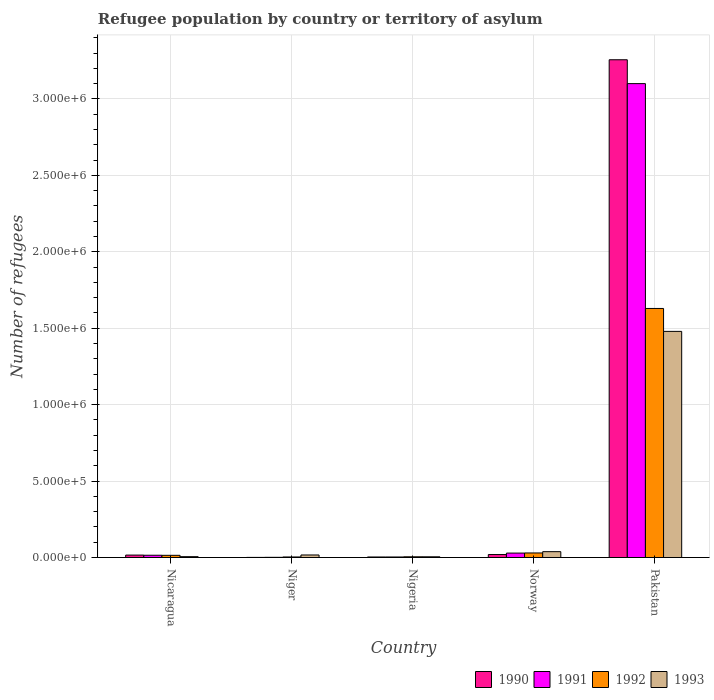How many different coloured bars are there?
Give a very brief answer. 4. How many groups of bars are there?
Ensure brevity in your answer.  5. Are the number of bars per tick equal to the number of legend labels?
Give a very brief answer. Yes. Are the number of bars on each tick of the X-axis equal?
Keep it short and to the point. Yes. How many bars are there on the 3rd tick from the right?
Ensure brevity in your answer.  4. What is the label of the 5th group of bars from the left?
Ensure brevity in your answer.  Pakistan. What is the number of refugees in 1992 in Nigeria?
Offer a terse response. 4782. Across all countries, what is the maximum number of refugees in 1993?
Your answer should be compact. 1.48e+06. Across all countries, what is the minimum number of refugees in 1990?
Provide a short and direct response. 792. In which country was the number of refugees in 1991 minimum?
Offer a very short reply. Niger. What is the total number of refugees in 1990 in the graph?
Make the answer very short. 3.30e+06. What is the difference between the number of refugees in 1991 in Niger and that in Nigeria?
Offer a very short reply. -2188. What is the difference between the number of refugees in 1991 in Nigeria and the number of refugees in 1992 in Pakistan?
Your answer should be very brief. -1.63e+06. What is the average number of refugees in 1990 per country?
Your answer should be very brief. 6.59e+05. What is the difference between the number of refugees of/in 1993 and number of refugees of/in 1990 in Niger?
Provide a succinct answer. 1.59e+04. What is the ratio of the number of refugees in 1990 in Nicaragua to that in Nigeria?
Keep it short and to the point. 4.48. Is the number of refugees in 1993 in Nigeria less than that in Pakistan?
Make the answer very short. Yes. What is the difference between the highest and the second highest number of refugees in 1992?
Make the answer very short. 1.61e+06. What is the difference between the highest and the lowest number of refugees in 1993?
Provide a succinct answer. 1.47e+06. What does the 4th bar from the left in Niger represents?
Make the answer very short. 1993. What does the 2nd bar from the right in Pakistan represents?
Give a very brief answer. 1992. Is it the case that in every country, the sum of the number of refugees in 1992 and number of refugees in 1990 is greater than the number of refugees in 1991?
Your answer should be compact. Yes. How many bars are there?
Provide a short and direct response. 20. Are all the bars in the graph horizontal?
Your response must be concise. No. What is the difference between two consecutive major ticks on the Y-axis?
Your answer should be very brief. 5.00e+05. Are the values on the major ticks of Y-axis written in scientific E-notation?
Keep it short and to the point. Yes. Where does the legend appear in the graph?
Keep it short and to the point. Bottom right. How many legend labels are there?
Keep it short and to the point. 4. What is the title of the graph?
Give a very brief answer. Refugee population by country or territory of asylum. Does "1982" appear as one of the legend labels in the graph?
Offer a very short reply. No. What is the label or title of the Y-axis?
Offer a terse response. Number of refugees. What is the Number of refugees of 1990 in Nicaragua?
Make the answer very short. 1.60e+04. What is the Number of refugees in 1991 in Nicaragua?
Ensure brevity in your answer.  1.49e+04. What is the Number of refugees in 1992 in Nicaragua?
Make the answer very short. 1.44e+04. What is the Number of refugees in 1993 in Nicaragua?
Provide a short and direct response. 5643. What is the Number of refugees of 1990 in Niger?
Make the answer very short. 792. What is the Number of refugees of 1991 in Niger?
Ensure brevity in your answer.  1385. What is the Number of refugees of 1992 in Niger?
Ensure brevity in your answer.  3699. What is the Number of refugees in 1993 in Niger?
Give a very brief answer. 1.67e+04. What is the Number of refugees of 1990 in Nigeria?
Make the answer very short. 3571. What is the Number of refugees of 1991 in Nigeria?
Your answer should be very brief. 3573. What is the Number of refugees of 1992 in Nigeria?
Make the answer very short. 4782. What is the Number of refugees of 1993 in Nigeria?
Provide a short and direct response. 4829. What is the Number of refugees of 1990 in Norway?
Offer a very short reply. 1.96e+04. What is the Number of refugees in 1991 in Norway?
Offer a terse response. 2.91e+04. What is the Number of refugees in 1992 in Norway?
Make the answer very short. 2.98e+04. What is the Number of refugees in 1993 in Norway?
Your answer should be compact. 3.84e+04. What is the Number of refugees of 1990 in Pakistan?
Your answer should be very brief. 3.26e+06. What is the Number of refugees of 1991 in Pakistan?
Ensure brevity in your answer.  3.10e+06. What is the Number of refugees of 1992 in Pakistan?
Provide a short and direct response. 1.63e+06. What is the Number of refugees in 1993 in Pakistan?
Ensure brevity in your answer.  1.48e+06. Across all countries, what is the maximum Number of refugees of 1990?
Keep it short and to the point. 3.26e+06. Across all countries, what is the maximum Number of refugees of 1991?
Your response must be concise. 3.10e+06. Across all countries, what is the maximum Number of refugees in 1992?
Offer a very short reply. 1.63e+06. Across all countries, what is the maximum Number of refugees in 1993?
Offer a terse response. 1.48e+06. Across all countries, what is the minimum Number of refugees of 1990?
Your answer should be very brief. 792. Across all countries, what is the minimum Number of refugees of 1991?
Give a very brief answer. 1385. Across all countries, what is the minimum Number of refugees of 1992?
Provide a short and direct response. 3699. Across all countries, what is the minimum Number of refugees of 1993?
Your answer should be very brief. 4829. What is the total Number of refugees in 1990 in the graph?
Keep it short and to the point. 3.30e+06. What is the total Number of refugees in 1991 in the graph?
Your answer should be compact. 3.15e+06. What is the total Number of refugees in 1992 in the graph?
Make the answer very short. 1.68e+06. What is the total Number of refugees in 1993 in the graph?
Keep it short and to the point. 1.54e+06. What is the difference between the Number of refugees in 1990 in Nicaragua and that in Niger?
Ensure brevity in your answer.  1.52e+04. What is the difference between the Number of refugees of 1991 in Nicaragua and that in Niger?
Ensure brevity in your answer.  1.35e+04. What is the difference between the Number of refugees of 1992 in Nicaragua and that in Niger?
Your answer should be compact. 1.08e+04. What is the difference between the Number of refugees in 1993 in Nicaragua and that in Niger?
Your answer should be very brief. -1.10e+04. What is the difference between the Number of refugees in 1990 in Nicaragua and that in Nigeria?
Offer a terse response. 1.24e+04. What is the difference between the Number of refugees of 1991 in Nicaragua and that in Nigeria?
Provide a succinct answer. 1.14e+04. What is the difference between the Number of refugees of 1992 in Nicaragua and that in Nigeria?
Keep it short and to the point. 9668. What is the difference between the Number of refugees in 1993 in Nicaragua and that in Nigeria?
Provide a short and direct response. 814. What is the difference between the Number of refugees in 1990 in Nicaragua and that in Norway?
Your response must be concise. -3581. What is the difference between the Number of refugees of 1991 in Nicaragua and that in Norway?
Provide a succinct answer. -1.41e+04. What is the difference between the Number of refugees of 1992 in Nicaragua and that in Norway?
Your answer should be compact. -1.54e+04. What is the difference between the Number of refugees of 1993 in Nicaragua and that in Norway?
Your answer should be very brief. -3.27e+04. What is the difference between the Number of refugees in 1990 in Nicaragua and that in Pakistan?
Ensure brevity in your answer.  -3.24e+06. What is the difference between the Number of refugees in 1991 in Nicaragua and that in Pakistan?
Make the answer very short. -3.08e+06. What is the difference between the Number of refugees in 1992 in Nicaragua and that in Pakistan?
Make the answer very short. -1.61e+06. What is the difference between the Number of refugees in 1993 in Nicaragua and that in Pakistan?
Offer a terse response. -1.47e+06. What is the difference between the Number of refugees of 1990 in Niger and that in Nigeria?
Offer a terse response. -2779. What is the difference between the Number of refugees of 1991 in Niger and that in Nigeria?
Give a very brief answer. -2188. What is the difference between the Number of refugees in 1992 in Niger and that in Nigeria?
Offer a terse response. -1083. What is the difference between the Number of refugees of 1993 in Niger and that in Nigeria?
Ensure brevity in your answer.  1.19e+04. What is the difference between the Number of refugees in 1990 in Niger and that in Norway?
Keep it short and to the point. -1.88e+04. What is the difference between the Number of refugees in 1991 in Niger and that in Norway?
Provide a succinct answer. -2.77e+04. What is the difference between the Number of refugees in 1992 in Niger and that in Norway?
Offer a very short reply. -2.61e+04. What is the difference between the Number of refugees of 1993 in Niger and that in Norway?
Your answer should be very brief. -2.17e+04. What is the difference between the Number of refugees of 1990 in Niger and that in Pakistan?
Your answer should be compact. -3.26e+06. What is the difference between the Number of refugees of 1991 in Niger and that in Pakistan?
Keep it short and to the point. -3.10e+06. What is the difference between the Number of refugees of 1992 in Niger and that in Pakistan?
Your response must be concise. -1.63e+06. What is the difference between the Number of refugees in 1993 in Niger and that in Pakistan?
Your response must be concise. -1.46e+06. What is the difference between the Number of refugees of 1990 in Nigeria and that in Norway?
Offer a very short reply. -1.60e+04. What is the difference between the Number of refugees of 1991 in Nigeria and that in Norway?
Your response must be concise. -2.55e+04. What is the difference between the Number of refugees of 1992 in Nigeria and that in Norway?
Your response must be concise. -2.51e+04. What is the difference between the Number of refugees of 1993 in Nigeria and that in Norway?
Provide a succinct answer. -3.35e+04. What is the difference between the Number of refugees of 1990 in Nigeria and that in Pakistan?
Offer a very short reply. -3.25e+06. What is the difference between the Number of refugees of 1991 in Nigeria and that in Pakistan?
Make the answer very short. -3.10e+06. What is the difference between the Number of refugees of 1992 in Nigeria and that in Pakistan?
Make the answer very short. -1.62e+06. What is the difference between the Number of refugees in 1993 in Nigeria and that in Pakistan?
Provide a short and direct response. -1.47e+06. What is the difference between the Number of refugees of 1990 in Norway and that in Pakistan?
Ensure brevity in your answer.  -3.24e+06. What is the difference between the Number of refugees in 1991 in Norway and that in Pakistan?
Offer a terse response. -3.07e+06. What is the difference between the Number of refugees in 1992 in Norway and that in Pakistan?
Provide a succinct answer. -1.60e+06. What is the difference between the Number of refugees of 1993 in Norway and that in Pakistan?
Provide a short and direct response. -1.44e+06. What is the difference between the Number of refugees in 1990 in Nicaragua and the Number of refugees in 1991 in Niger?
Make the answer very short. 1.46e+04. What is the difference between the Number of refugees of 1990 in Nicaragua and the Number of refugees of 1992 in Niger?
Your answer should be compact. 1.23e+04. What is the difference between the Number of refugees of 1990 in Nicaragua and the Number of refugees of 1993 in Niger?
Your answer should be compact. -692. What is the difference between the Number of refugees in 1991 in Nicaragua and the Number of refugees in 1992 in Niger?
Make the answer very short. 1.12e+04. What is the difference between the Number of refugees in 1991 in Nicaragua and the Number of refugees in 1993 in Niger?
Offer a terse response. -1759. What is the difference between the Number of refugees in 1992 in Nicaragua and the Number of refugees in 1993 in Niger?
Ensure brevity in your answer.  -2242. What is the difference between the Number of refugees of 1990 in Nicaragua and the Number of refugees of 1991 in Nigeria?
Give a very brief answer. 1.24e+04. What is the difference between the Number of refugees of 1990 in Nicaragua and the Number of refugees of 1992 in Nigeria?
Offer a very short reply. 1.12e+04. What is the difference between the Number of refugees of 1990 in Nicaragua and the Number of refugees of 1993 in Nigeria?
Provide a succinct answer. 1.12e+04. What is the difference between the Number of refugees in 1991 in Nicaragua and the Number of refugees in 1992 in Nigeria?
Your response must be concise. 1.02e+04. What is the difference between the Number of refugees of 1991 in Nicaragua and the Number of refugees of 1993 in Nigeria?
Provide a succinct answer. 1.01e+04. What is the difference between the Number of refugees in 1992 in Nicaragua and the Number of refugees in 1993 in Nigeria?
Your response must be concise. 9621. What is the difference between the Number of refugees of 1990 in Nicaragua and the Number of refugees of 1991 in Norway?
Your answer should be very brief. -1.31e+04. What is the difference between the Number of refugees in 1990 in Nicaragua and the Number of refugees in 1992 in Norway?
Offer a terse response. -1.38e+04. What is the difference between the Number of refugees of 1990 in Nicaragua and the Number of refugees of 1993 in Norway?
Make the answer very short. -2.24e+04. What is the difference between the Number of refugees of 1991 in Nicaragua and the Number of refugees of 1992 in Norway?
Make the answer very short. -1.49e+04. What is the difference between the Number of refugees in 1991 in Nicaragua and the Number of refugees in 1993 in Norway?
Keep it short and to the point. -2.34e+04. What is the difference between the Number of refugees of 1992 in Nicaragua and the Number of refugees of 1993 in Norway?
Provide a short and direct response. -2.39e+04. What is the difference between the Number of refugees in 1990 in Nicaragua and the Number of refugees in 1991 in Pakistan?
Your answer should be compact. -3.08e+06. What is the difference between the Number of refugees in 1990 in Nicaragua and the Number of refugees in 1992 in Pakistan?
Your answer should be compact. -1.61e+06. What is the difference between the Number of refugees in 1990 in Nicaragua and the Number of refugees in 1993 in Pakistan?
Offer a very short reply. -1.46e+06. What is the difference between the Number of refugees of 1991 in Nicaragua and the Number of refugees of 1992 in Pakistan?
Your answer should be very brief. -1.61e+06. What is the difference between the Number of refugees of 1991 in Nicaragua and the Number of refugees of 1993 in Pakistan?
Your answer should be compact. -1.46e+06. What is the difference between the Number of refugees of 1992 in Nicaragua and the Number of refugees of 1993 in Pakistan?
Make the answer very short. -1.46e+06. What is the difference between the Number of refugees of 1990 in Niger and the Number of refugees of 1991 in Nigeria?
Make the answer very short. -2781. What is the difference between the Number of refugees of 1990 in Niger and the Number of refugees of 1992 in Nigeria?
Provide a short and direct response. -3990. What is the difference between the Number of refugees in 1990 in Niger and the Number of refugees in 1993 in Nigeria?
Make the answer very short. -4037. What is the difference between the Number of refugees of 1991 in Niger and the Number of refugees of 1992 in Nigeria?
Your answer should be compact. -3397. What is the difference between the Number of refugees in 1991 in Niger and the Number of refugees in 1993 in Nigeria?
Provide a short and direct response. -3444. What is the difference between the Number of refugees in 1992 in Niger and the Number of refugees in 1993 in Nigeria?
Offer a terse response. -1130. What is the difference between the Number of refugees in 1990 in Niger and the Number of refugees in 1991 in Norway?
Offer a very short reply. -2.83e+04. What is the difference between the Number of refugees in 1990 in Niger and the Number of refugees in 1992 in Norway?
Provide a succinct answer. -2.91e+04. What is the difference between the Number of refugees of 1990 in Niger and the Number of refugees of 1993 in Norway?
Give a very brief answer. -3.76e+04. What is the difference between the Number of refugees in 1991 in Niger and the Number of refugees in 1992 in Norway?
Make the answer very short. -2.85e+04. What is the difference between the Number of refugees in 1991 in Niger and the Number of refugees in 1993 in Norway?
Your answer should be very brief. -3.70e+04. What is the difference between the Number of refugees in 1992 in Niger and the Number of refugees in 1993 in Norway?
Offer a very short reply. -3.47e+04. What is the difference between the Number of refugees of 1990 in Niger and the Number of refugees of 1991 in Pakistan?
Ensure brevity in your answer.  -3.10e+06. What is the difference between the Number of refugees in 1990 in Niger and the Number of refugees in 1992 in Pakistan?
Provide a short and direct response. -1.63e+06. What is the difference between the Number of refugees of 1990 in Niger and the Number of refugees of 1993 in Pakistan?
Provide a succinct answer. -1.48e+06. What is the difference between the Number of refugees of 1991 in Niger and the Number of refugees of 1992 in Pakistan?
Provide a short and direct response. -1.63e+06. What is the difference between the Number of refugees in 1991 in Niger and the Number of refugees in 1993 in Pakistan?
Provide a short and direct response. -1.48e+06. What is the difference between the Number of refugees in 1992 in Niger and the Number of refugees in 1993 in Pakistan?
Ensure brevity in your answer.  -1.48e+06. What is the difference between the Number of refugees in 1990 in Nigeria and the Number of refugees in 1991 in Norway?
Your answer should be compact. -2.55e+04. What is the difference between the Number of refugees of 1990 in Nigeria and the Number of refugees of 1992 in Norway?
Provide a succinct answer. -2.63e+04. What is the difference between the Number of refugees of 1990 in Nigeria and the Number of refugees of 1993 in Norway?
Provide a succinct answer. -3.48e+04. What is the difference between the Number of refugees in 1991 in Nigeria and the Number of refugees in 1992 in Norway?
Give a very brief answer. -2.63e+04. What is the difference between the Number of refugees in 1991 in Nigeria and the Number of refugees in 1993 in Norway?
Offer a terse response. -3.48e+04. What is the difference between the Number of refugees in 1992 in Nigeria and the Number of refugees in 1993 in Norway?
Offer a very short reply. -3.36e+04. What is the difference between the Number of refugees in 1990 in Nigeria and the Number of refugees in 1991 in Pakistan?
Provide a short and direct response. -3.10e+06. What is the difference between the Number of refugees in 1990 in Nigeria and the Number of refugees in 1992 in Pakistan?
Ensure brevity in your answer.  -1.63e+06. What is the difference between the Number of refugees in 1990 in Nigeria and the Number of refugees in 1993 in Pakistan?
Give a very brief answer. -1.48e+06. What is the difference between the Number of refugees of 1991 in Nigeria and the Number of refugees of 1992 in Pakistan?
Give a very brief answer. -1.63e+06. What is the difference between the Number of refugees of 1991 in Nigeria and the Number of refugees of 1993 in Pakistan?
Your answer should be very brief. -1.48e+06. What is the difference between the Number of refugees of 1992 in Nigeria and the Number of refugees of 1993 in Pakistan?
Ensure brevity in your answer.  -1.47e+06. What is the difference between the Number of refugees in 1990 in Norway and the Number of refugees in 1991 in Pakistan?
Your answer should be compact. -3.08e+06. What is the difference between the Number of refugees of 1990 in Norway and the Number of refugees of 1992 in Pakistan?
Provide a succinct answer. -1.61e+06. What is the difference between the Number of refugees in 1990 in Norway and the Number of refugees in 1993 in Pakistan?
Give a very brief answer. -1.46e+06. What is the difference between the Number of refugees of 1991 in Norway and the Number of refugees of 1992 in Pakistan?
Provide a succinct answer. -1.60e+06. What is the difference between the Number of refugees of 1991 in Norway and the Number of refugees of 1993 in Pakistan?
Offer a very short reply. -1.45e+06. What is the difference between the Number of refugees of 1992 in Norway and the Number of refugees of 1993 in Pakistan?
Your response must be concise. -1.45e+06. What is the average Number of refugees in 1990 per country?
Make the answer very short. 6.59e+05. What is the average Number of refugees in 1991 per country?
Make the answer very short. 6.30e+05. What is the average Number of refugees of 1992 per country?
Give a very brief answer. 3.36e+05. What is the average Number of refugees in 1993 per country?
Your answer should be very brief. 3.09e+05. What is the difference between the Number of refugees of 1990 and Number of refugees of 1991 in Nicaragua?
Keep it short and to the point. 1067. What is the difference between the Number of refugees in 1990 and Number of refugees in 1992 in Nicaragua?
Provide a succinct answer. 1550. What is the difference between the Number of refugees of 1990 and Number of refugees of 1993 in Nicaragua?
Ensure brevity in your answer.  1.04e+04. What is the difference between the Number of refugees in 1991 and Number of refugees in 1992 in Nicaragua?
Your response must be concise. 483. What is the difference between the Number of refugees in 1991 and Number of refugees in 1993 in Nicaragua?
Your response must be concise. 9290. What is the difference between the Number of refugees in 1992 and Number of refugees in 1993 in Nicaragua?
Your response must be concise. 8807. What is the difference between the Number of refugees in 1990 and Number of refugees in 1991 in Niger?
Provide a short and direct response. -593. What is the difference between the Number of refugees of 1990 and Number of refugees of 1992 in Niger?
Keep it short and to the point. -2907. What is the difference between the Number of refugees of 1990 and Number of refugees of 1993 in Niger?
Provide a succinct answer. -1.59e+04. What is the difference between the Number of refugees of 1991 and Number of refugees of 1992 in Niger?
Give a very brief answer. -2314. What is the difference between the Number of refugees in 1991 and Number of refugees in 1993 in Niger?
Your answer should be compact. -1.53e+04. What is the difference between the Number of refugees of 1992 and Number of refugees of 1993 in Niger?
Offer a terse response. -1.30e+04. What is the difference between the Number of refugees in 1990 and Number of refugees in 1991 in Nigeria?
Make the answer very short. -2. What is the difference between the Number of refugees of 1990 and Number of refugees of 1992 in Nigeria?
Keep it short and to the point. -1211. What is the difference between the Number of refugees of 1990 and Number of refugees of 1993 in Nigeria?
Your answer should be very brief. -1258. What is the difference between the Number of refugees of 1991 and Number of refugees of 1992 in Nigeria?
Ensure brevity in your answer.  -1209. What is the difference between the Number of refugees in 1991 and Number of refugees in 1993 in Nigeria?
Your answer should be compact. -1256. What is the difference between the Number of refugees in 1992 and Number of refugees in 1993 in Nigeria?
Keep it short and to the point. -47. What is the difference between the Number of refugees of 1990 and Number of refugees of 1991 in Norway?
Keep it short and to the point. -9473. What is the difference between the Number of refugees in 1990 and Number of refugees in 1992 in Norway?
Make the answer very short. -1.03e+04. What is the difference between the Number of refugees in 1990 and Number of refugees in 1993 in Norway?
Provide a short and direct response. -1.88e+04. What is the difference between the Number of refugees of 1991 and Number of refugees of 1992 in Norway?
Keep it short and to the point. -792. What is the difference between the Number of refugees in 1991 and Number of refugees in 1993 in Norway?
Offer a very short reply. -9321. What is the difference between the Number of refugees in 1992 and Number of refugees in 1993 in Norway?
Your answer should be compact. -8529. What is the difference between the Number of refugees in 1990 and Number of refugees in 1991 in Pakistan?
Provide a short and direct response. 1.56e+05. What is the difference between the Number of refugees of 1990 and Number of refugees of 1992 in Pakistan?
Ensure brevity in your answer.  1.63e+06. What is the difference between the Number of refugees in 1990 and Number of refugees in 1993 in Pakistan?
Provide a short and direct response. 1.78e+06. What is the difference between the Number of refugees of 1991 and Number of refugees of 1992 in Pakistan?
Provide a succinct answer. 1.47e+06. What is the difference between the Number of refugees in 1991 and Number of refugees in 1993 in Pakistan?
Offer a very short reply. 1.62e+06. What is the difference between the Number of refugees of 1992 and Number of refugees of 1993 in Pakistan?
Make the answer very short. 1.50e+05. What is the ratio of the Number of refugees of 1990 in Nicaragua to that in Niger?
Ensure brevity in your answer.  20.2. What is the ratio of the Number of refugees in 1991 in Nicaragua to that in Niger?
Give a very brief answer. 10.78. What is the ratio of the Number of refugees of 1992 in Nicaragua to that in Niger?
Keep it short and to the point. 3.91. What is the ratio of the Number of refugees in 1993 in Nicaragua to that in Niger?
Offer a terse response. 0.34. What is the ratio of the Number of refugees of 1990 in Nicaragua to that in Nigeria?
Your answer should be compact. 4.48. What is the ratio of the Number of refugees of 1991 in Nicaragua to that in Nigeria?
Give a very brief answer. 4.18. What is the ratio of the Number of refugees of 1992 in Nicaragua to that in Nigeria?
Your answer should be very brief. 3.02. What is the ratio of the Number of refugees in 1993 in Nicaragua to that in Nigeria?
Offer a very short reply. 1.17. What is the ratio of the Number of refugees of 1990 in Nicaragua to that in Norway?
Ensure brevity in your answer.  0.82. What is the ratio of the Number of refugees in 1991 in Nicaragua to that in Norway?
Keep it short and to the point. 0.51. What is the ratio of the Number of refugees of 1992 in Nicaragua to that in Norway?
Offer a very short reply. 0.48. What is the ratio of the Number of refugees of 1993 in Nicaragua to that in Norway?
Offer a very short reply. 0.15. What is the ratio of the Number of refugees in 1990 in Nicaragua to that in Pakistan?
Provide a short and direct response. 0. What is the ratio of the Number of refugees in 1991 in Nicaragua to that in Pakistan?
Your answer should be compact. 0. What is the ratio of the Number of refugees in 1992 in Nicaragua to that in Pakistan?
Make the answer very short. 0.01. What is the ratio of the Number of refugees of 1993 in Nicaragua to that in Pakistan?
Your answer should be compact. 0. What is the ratio of the Number of refugees of 1990 in Niger to that in Nigeria?
Provide a succinct answer. 0.22. What is the ratio of the Number of refugees in 1991 in Niger to that in Nigeria?
Give a very brief answer. 0.39. What is the ratio of the Number of refugees in 1992 in Niger to that in Nigeria?
Provide a succinct answer. 0.77. What is the ratio of the Number of refugees in 1993 in Niger to that in Nigeria?
Provide a short and direct response. 3.46. What is the ratio of the Number of refugees in 1990 in Niger to that in Norway?
Ensure brevity in your answer.  0.04. What is the ratio of the Number of refugees of 1991 in Niger to that in Norway?
Your answer should be compact. 0.05. What is the ratio of the Number of refugees of 1992 in Niger to that in Norway?
Your answer should be very brief. 0.12. What is the ratio of the Number of refugees in 1993 in Niger to that in Norway?
Provide a succinct answer. 0.43. What is the ratio of the Number of refugees of 1990 in Niger to that in Pakistan?
Your response must be concise. 0. What is the ratio of the Number of refugees in 1992 in Niger to that in Pakistan?
Offer a terse response. 0. What is the ratio of the Number of refugees in 1993 in Niger to that in Pakistan?
Ensure brevity in your answer.  0.01. What is the ratio of the Number of refugees of 1990 in Nigeria to that in Norway?
Ensure brevity in your answer.  0.18. What is the ratio of the Number of refugees of 1991 in Nigeria to that in Norway?
Ensure brevity in your answer.  0.12. What is the ratio of the Number of refugees of 1992 in Nigeria to that in Norway?
Offer a very short reply. 0.16. What is the ratio of the Number of refugees in 1993 in Nigeria to that in Norway?
Make the answer very short. 0.13. What is the ratio of the Number of refugees of 1990 in Nigeria to that in Pakistan?
Your answer should be very brief. 0. What is the ratio of the Number of refugees in 1991 in Nigeria to that in Pakistan?
Provide a short and direct response. 0. What is the ratio of the Number of refugees of 1992 in Nigeria to that in Pakistan?
Make the answer very short. 0. What is the ratio of the Number of refugees in 1993 in Nigeria to that in Pakistan?
Your answer should be very brief. 0. What is the ratio of the Number of refugees of 1990 in Norway to that in Pakistan?
Provide a short and direct response. 0.01. What is the ratio of the Number of refugees of 1991 in Norway to that in Pakistan?
Offer a very short reply. 0.01. What is the ratio of the Number of refugees in 1992 in Norway to that in Pakistan?
Make the answer very short. 0.02. What is the ratio of the Number of refugees of 1993 in Norway to that in Pakistan?
Keep it short and to the point. 0.03. What is the difference between the highest and the second highest Number of refugees in 1990?
Ensure brevity in your answer.  3.24e+06. What is the difference between the highest and the second highest Number of refugees of 1991?
Give a very brief answer. 3.07e+06. What is the difference between the highest and the second highest Number of refugees of 1992?
Offer a very short reply. 1.60e+06. What is the difference between the highest and the second highest Number of refugees in 1993?
Your answer should be very brief. 1.44e+06. What is the difference between the highest and the lowest Number of refugees in 1990?
Ensure brevity in your answer.  3.26e+06. What is the difference between the highest and the lowest Number of refugees of 1991?
Make the answer very short. 3.10e+06. What is the difference between the highest and the lowest Number of refugees of 1992?
Offer a very short reply. 1.63e+06. What is the difference between the highest and the lowest Number of refugees of 1993?
Provide a short and direct response. 1.47e+06. 